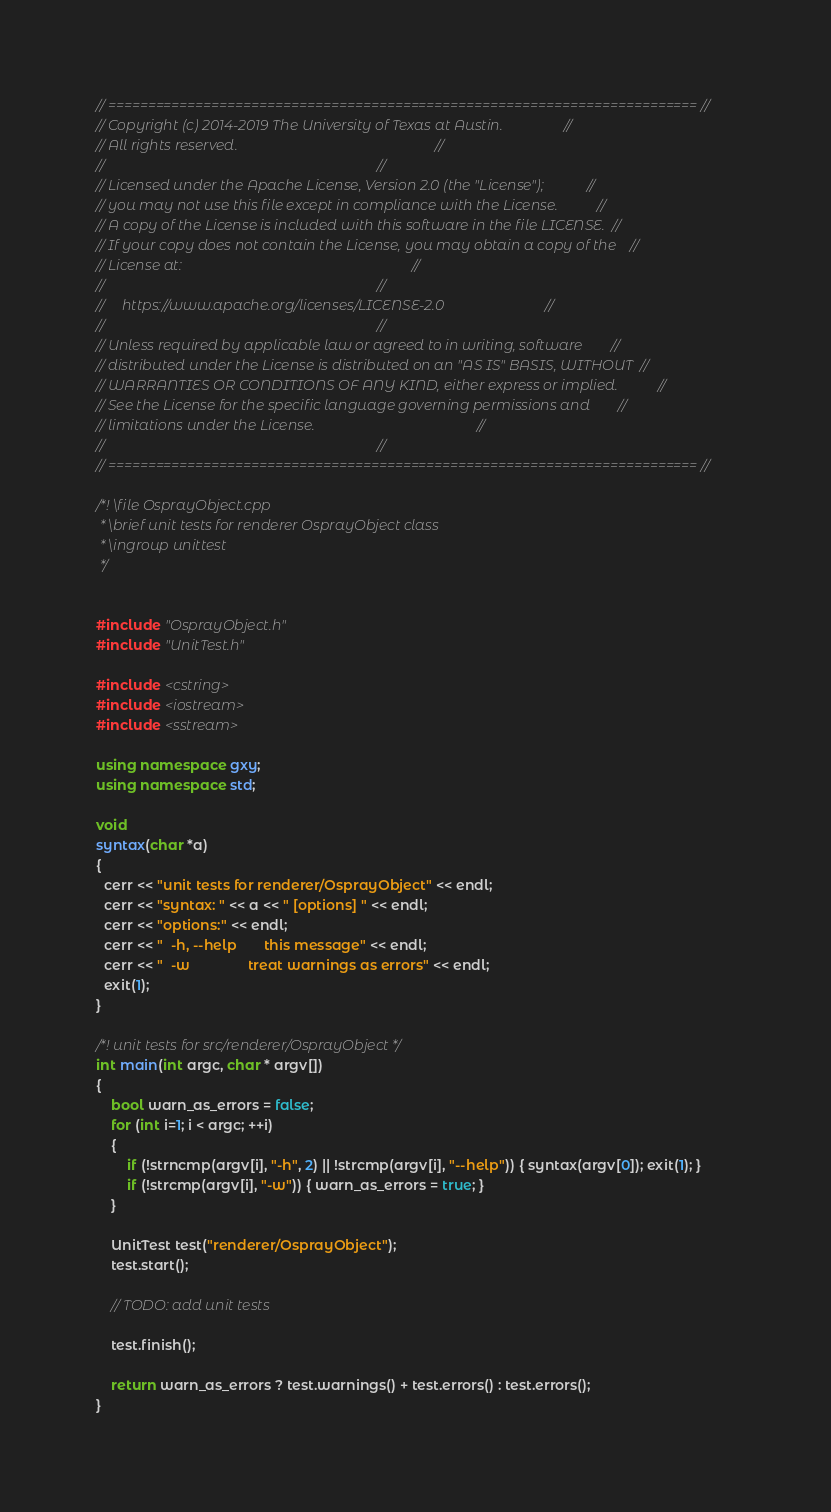Convert code to text. <code><loc_0><loc_0><loc_500><loc_500><_C++_>// ========================================================================== //
// Copyright (c) 2014-2019 The University of Texas at Austin.                 //
// All rights reserved.                                                       //
//                                                                            //
// Licensed under the Apache License, Version 2.0 (the "License");            //
// you may not use this file except in compliance with the License.           //
// A copy of the License is included with this software in the file LICENSE.  //
// If your copy does not contain the License, you may obtain a copy of the    //
// License at:                                                                //
//                                                                            //
//     https://www.apache.org/licenses/LICENSE-2.0                            //
//                                                                            //
// Unless required by applicable law or agreed to in writing, software        //
// distributed under the License is distributed on an "AS IS" BASIS, WITHOUT  //
// WARRANTIES OR CONDITIONS OF ANY KIND, either express or implied.           //
// See the License for the specific language governing permissions and        //
// limitations under the License.                                             //
//                                                                            //
// ========================================================================== //

/*! \file OsprayObject.cpp 
 * \brief unit tests for renderer OsprayObject class
 * \ingroup unittest
 */


#include "OsprayObject.h"
#include "UnitTest.h"

#include <cstring>
#include <iostream>
#include <sstream>

using namespace gxy;
using namespace std;

void
syntax(char *a)
{
  cerr << "unit tests for renderer/OsprayObject" << endl;
  cerr << "syntax: " << a << " [options] " << endl;
  cerr << "options:" << endl;
  cerr << "  -h, --help       this message" << endl;
  cerr << "  -w               treat warnings as errors" << endl;
  exit(1);
}

/*! unit tests for src/renderer/OsprayObject */
int main(int argc, char * argv[])
{
	bool warn_as_errors = false;
	for (int i=1; i < argc; ++i)
	{
		if (!strncmp(argv[i], "-h", 2) || !strcmp(argv[i], "--help")) { syntax(argv[0]); exit(1); }
		if (!strcmp(argv[i], "-w")) { warn_as_errors = true; }
	}

	UnitTest test("renderer/OsprayObject");
	test.start();

	// TODO: add unit tests

	test.finish();

	return warn_as_errors ? test.warnings() + test.errors() : test.errors();
}</code> 